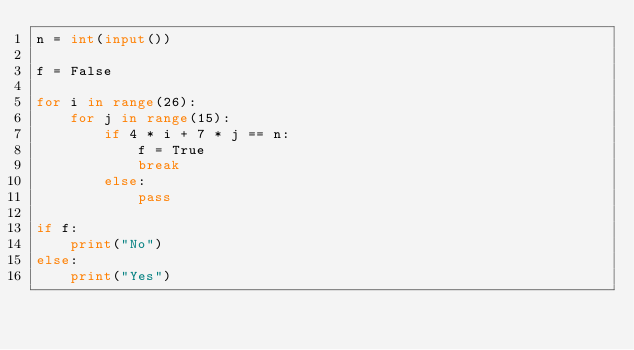<code> <loc_0><loc_0><loc_500><loc_500><_Python_>n = int(input())

f = False

for i in range(26):
    for j in range(15):
        if 4 * i + 7 * j == n:
            f = True
            break
        else:
            pass

if f:
    print("No")
else:
    print("Yes")</code> 